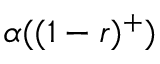Convert formula to latex. <formula><loc_0><loc_0><loc_500><loc_500>\alpha ( ( 1 - r ) ^ { + } )</formula> 